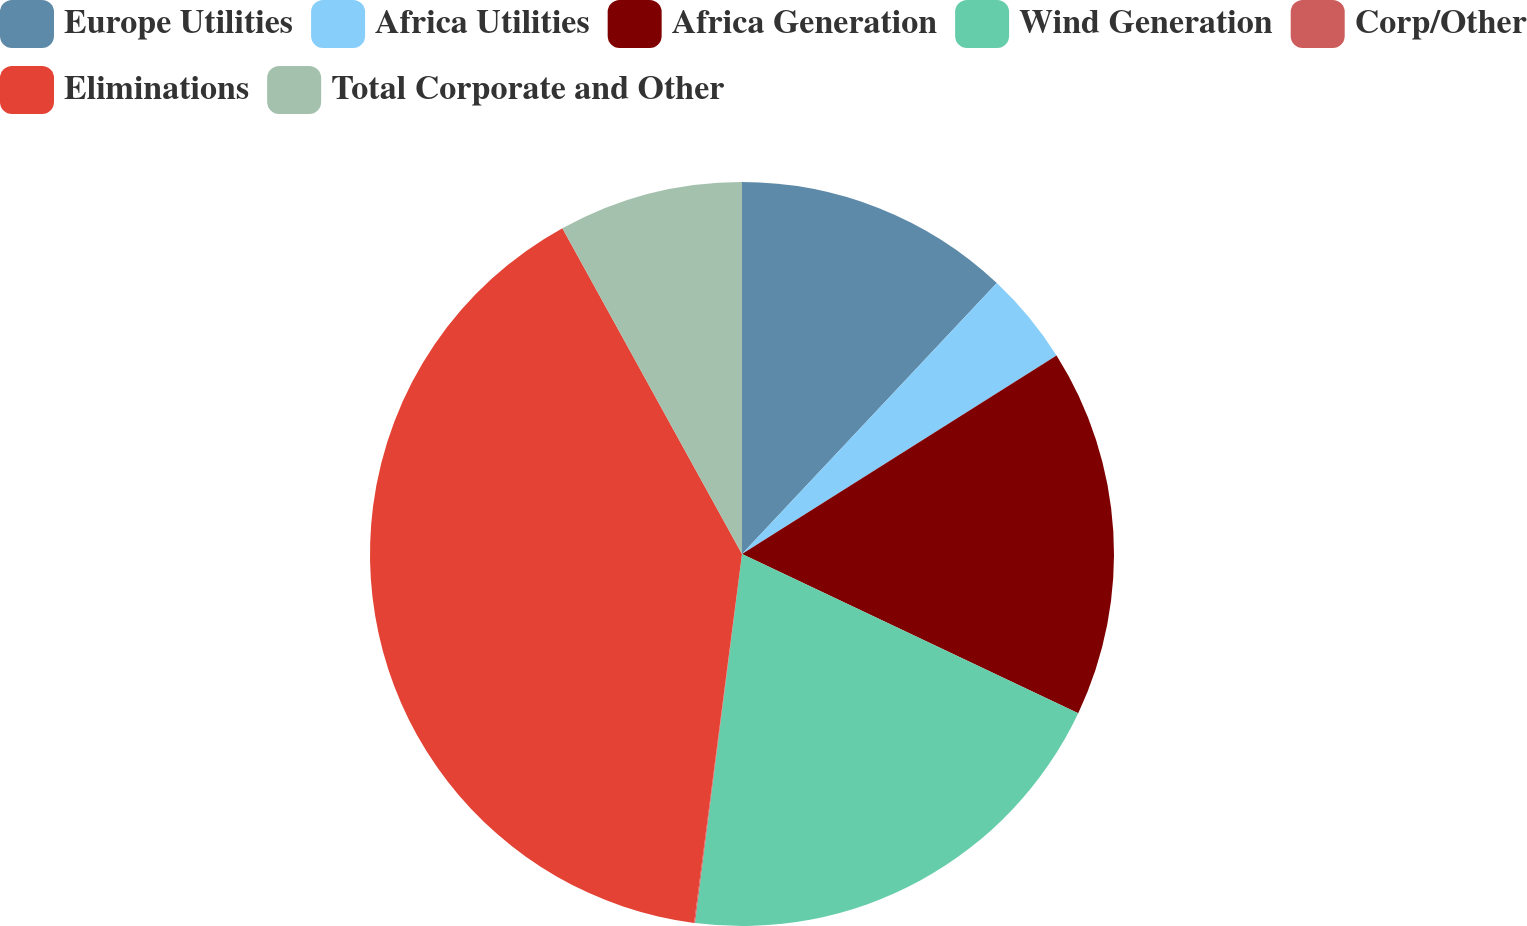Convert chart to OTSL. <chart><loc_0><loc_0><loc_500><loc_500><pie_chart><fcel>Europe Utilities<fcel>Africa Utilities<fcel>Africa Generation<fcel>Wind Generation<fcel>Corp/Other<fcel>Eliminations<fcel>Total Corporate and Other<nl><fcel>12.01%<fcel>4.03%<fcel>16.0%<fcel>19.98%<fcel>0.04%<fcel>39.93%<fcel>8.02%<nl></chart> 